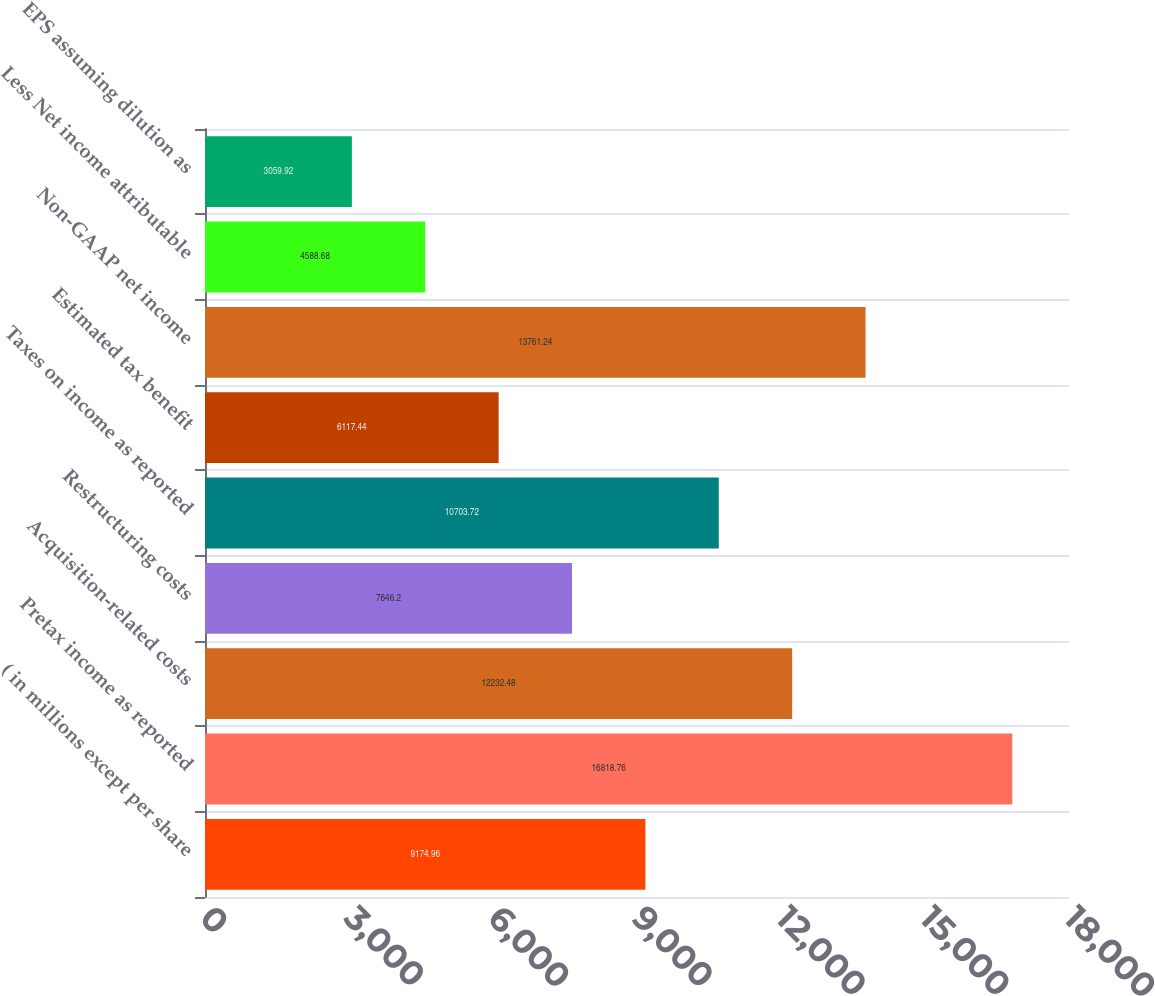<chart> <loc_0><loc_0><loc_500><loc_500><bar_chart><fcel>( in millions except per share<fcel>Pretax income as reported<fcel>Acquisition-related costs<fcel>Restructuring costs<fcel>Taxes on income as reported<fcel>Estimated tax benefit<fcel>Non-GAAP net income<fcel>Less Net income attributable<fcel>EPS assuming dilution as<nl><fcel>9174.96<fcel>16818.8<fcel>12232.5<fcel>7646.2<fcel>10703.7<fcel>6117.44<fcel>13761.2<fcel>4588.68<fcel>3059.92<nl></chart> 